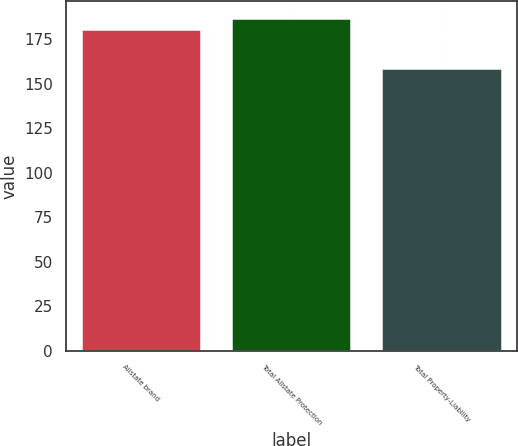<chart> <loc_0><loc_0><loc_500><loc_500><bar_chart><fcel>Allstate brand<fcel>Total Allstate Protection<fcel>Total Property-Liability<nl><fcel>181<fcel>187<fcel>159<nl></chart> 